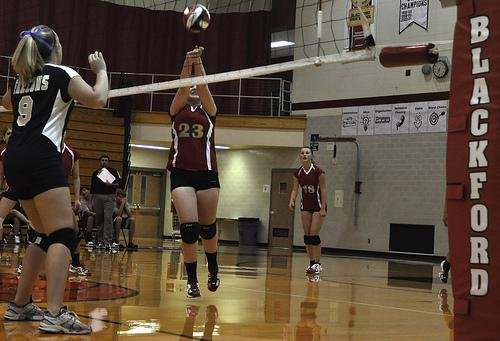Question: when will the black team hit the ball?
Choices:
A. When they are up to bat.
B. During the next inning.
C. After the pitcher throws it.
D. When it's on their side.
Answer with the letter. Answer: D Question: who is hitting the ball?
Choices:
A. Number 12.
B. Number 45.
C. Number 8.
D. Number 23.
Answer with the letter. Answer: D Question: why is the girl in maroon jumping?
Choices:
A. To throw a ball.
B. To hit the ball.
C. To kick a ball.
D. To catch a ball.
Answer with the letter. Answer: B Question: what game is this?
Choices:
A. Football.
B. Tennis.
C. Baseball.
D. Volleyball.
Answer with the letter. Answer: D Question: what kind of shorts are they wearing?
Choices:
A. Cotton.
B. Polyester.
C. Denim.
D. Spandex.
Answer with the letter. Answer: D Question: what is on the girls' legs?
Choices:
A. Shin guards.
B. Tights.
C. Knee Pads.
D. Sweatpants.
Answer with the letter. Answer: C 